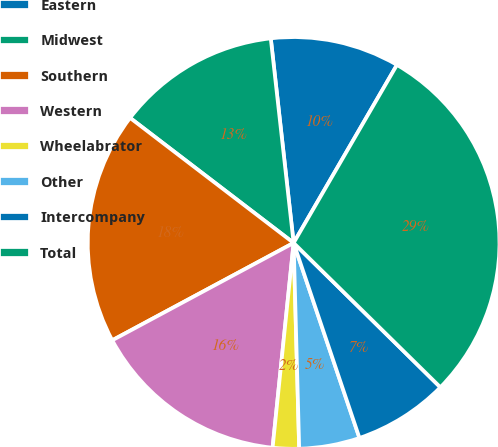<chart> <loc_0><loc_0><loc_500><loc_500><pie_chart><fcel>Eastern<fcel>Midwest<fcel>Southern<fcel>Western<fcel>Wheelabrator<fcel>Other<fcel>Intercompany<fcel>Total<nl><fcel>10.14%<fcel>12.84%<fcel>18.23%<fcel>15.53%<fcel>2.06%<fcel>4.75%<fcel>7.45%<fcel>29.0%<nl></chart> 